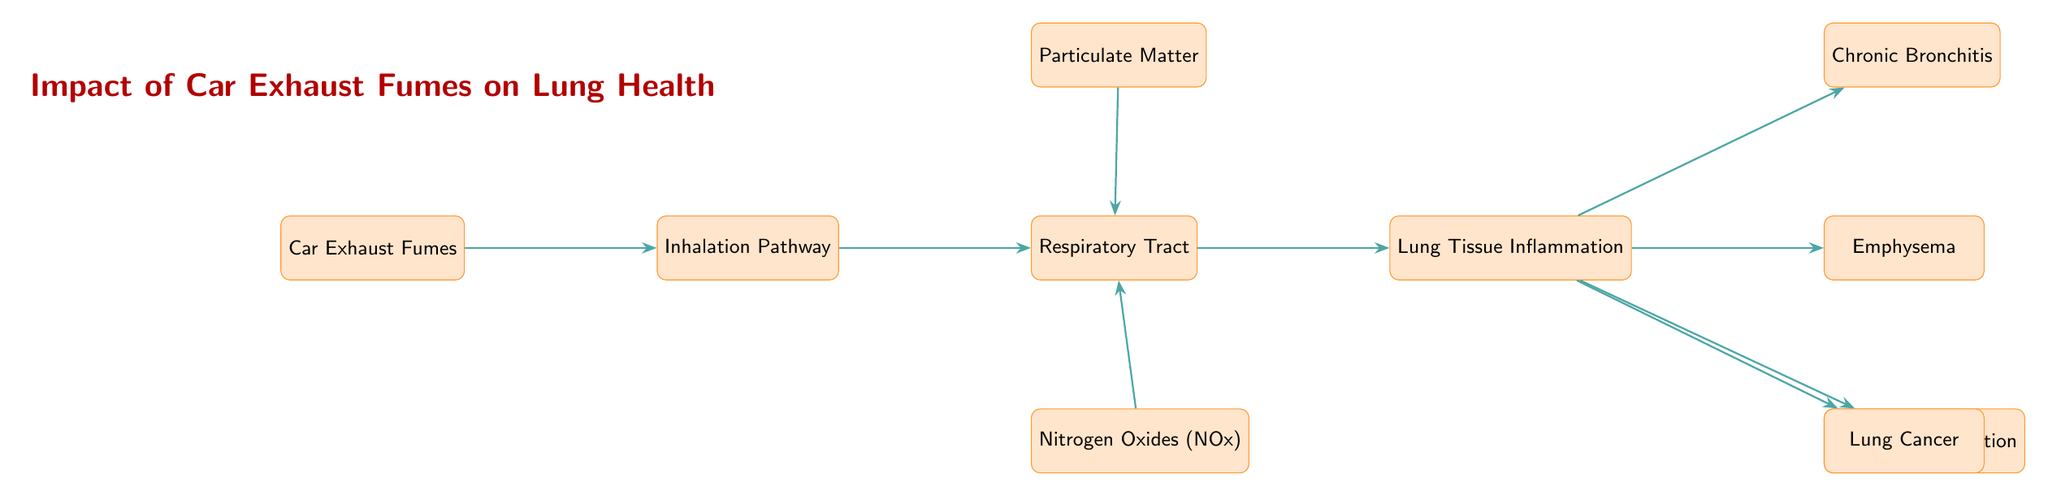What is the starting point of the diagram? The starting point of the diagram is "Car Exhaust Fumes," which is the first node listed on the left side.
Answer: Car Exhaust Fumes What enters through the inhalation pathway? According to the diagram, the "Car Exhaust Fumes" enter the inhalation pathway as indicated by the directed edge.
Answer: Car Exhaust Fumes How many chronic effects on lung health are shown? The diagram lists four chronic effects resulting from lung tissue inflammation: Chronic Bronchitis, Emphysema, Asthma Exacerbation, and Lung Cancer.
Answer: 4 Which pollutants are shown to affect the respiratory tract? The diagram indicates that "Particulate Matter" and "Nitrogen Oxides (NOx)" are the pollutants that affect the respiratory tract.
Answer: Particulate Matter and Nitrogen Oxides (NOx) What is the relationship between respiratory tract and lung tissue inflammation? The relationship indicates that the respiratory tract causes lung tissue inflammation as shown by the directed edge labelled "causes."
Answer: causes What happens after lung tissue inflammation occurs? After lung tissue inflammation occurs, it leads to chronic bronchitis, emphysema, and triggers asthma exacerbation. This implies a sequence of medical conditions.
Answer: Chronic Bronchitis, Emphysema, Asthma Exacerbation What might result from lung tissue inflammation according to the diagram? According to the diagram, lung tissue inflammation may result in lung cancer as indicated by the edge labelled "may result in."
Answer: Lung Cancer 